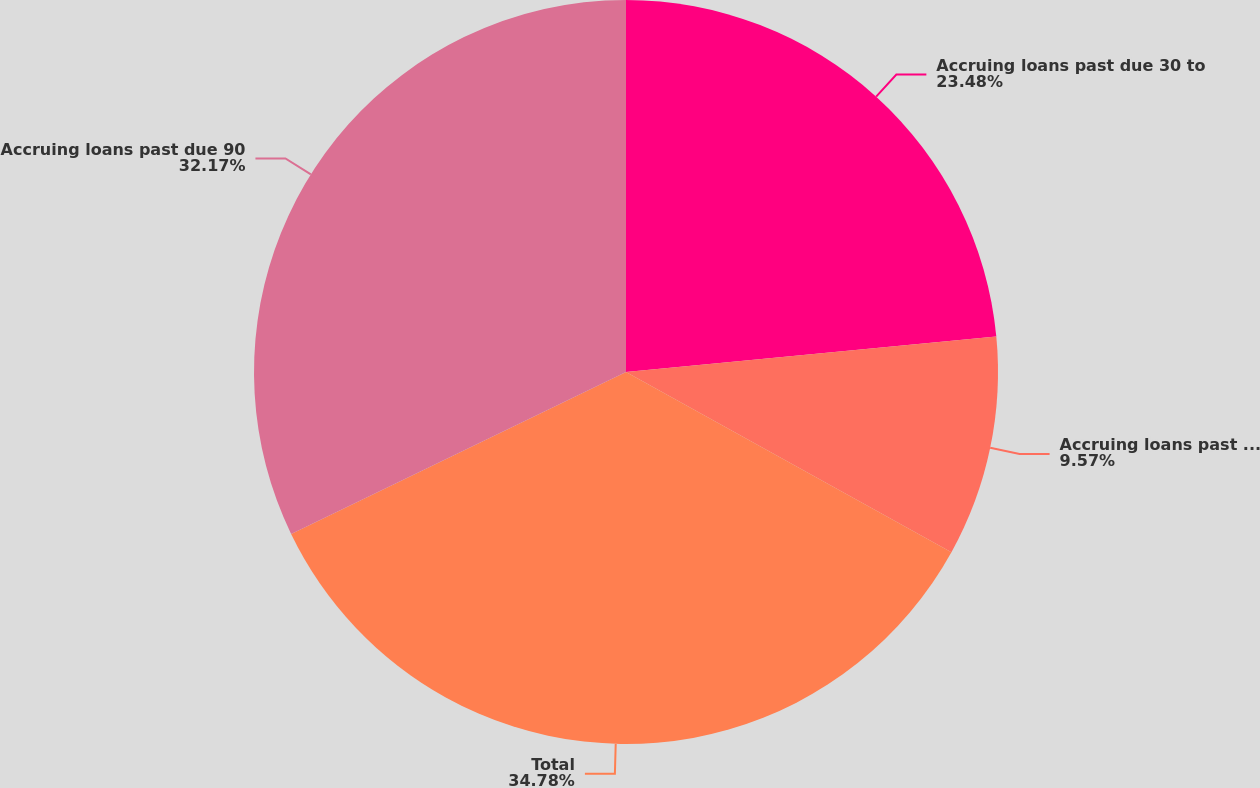Convert chart. <chart><loc_0><loc_0><loc_500><loc_500><pie_chart><fcel>Accruing loans past due 30 to<fcel>Accruing loans past due 60 to<fcel>Total<fcel>Accruing loans past due 90<nl><fcel>23.48%<fcel>9.57%<fcel>34.78%<fcel>32.17%<nl></chart> 